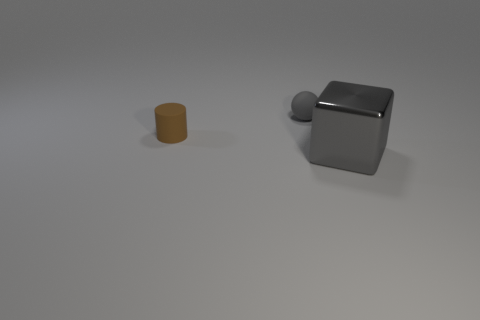Add 3 small gray matte spheres. How many objects exist? 6 Subtract all cylinders. How many objects are left? 2 Subtract 0 yellow spheres. How many objects are left? 3 Subtract all big purple spheres. Subtract all small brown matte objects. How many objects are left? 2 Add 1 small gray balls. How many small gray balls are left? 2 Add 3 large yellow matte cylinders. How many large yellow matte cylinders exist? 3 